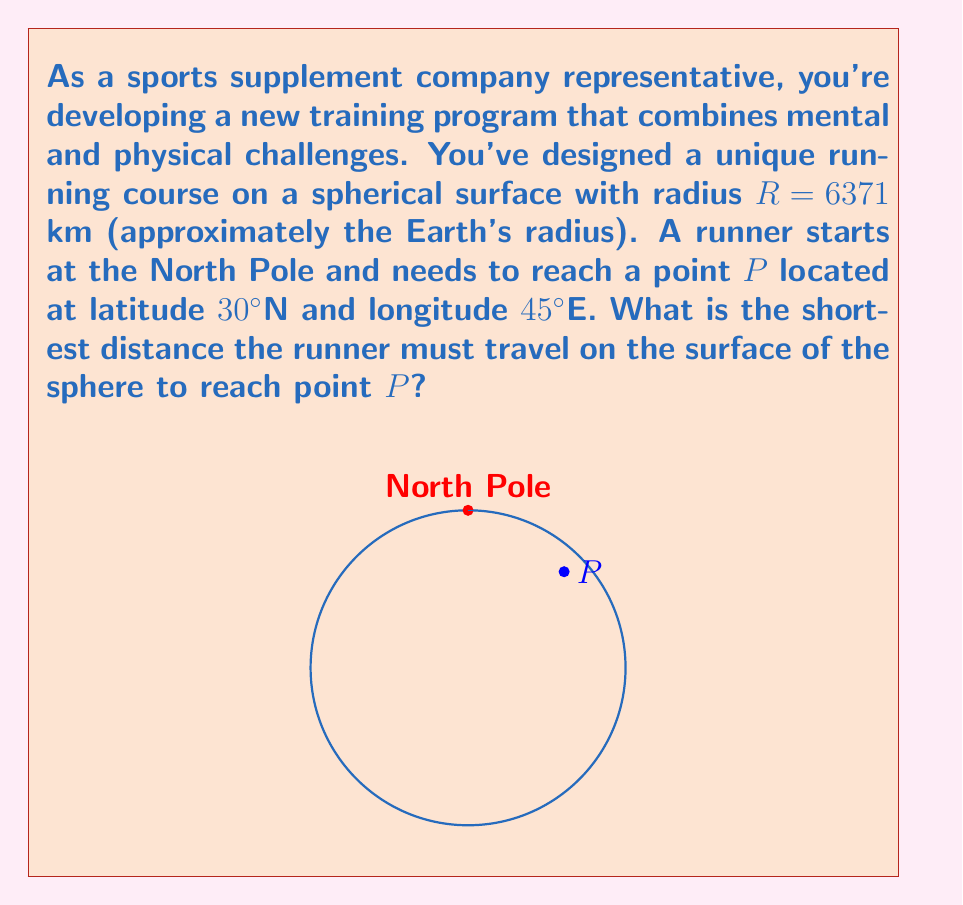Provide a solution to this math problem. To solve this problem, we need to use concepts from spherical geometry:

1) The shortest path between two points on a sphere is along a great circle, which is the intersection of the sphere with a plane passing through its center and both points.

2) The distance along this great circle is given by the arc length formula:
   $$s = R\theta$$
   where $s$ is the arc length, $R$ is the radius, and $\theta$ is the central angle in radians.

3) To find $\theta$, we can use the spherical law of cosines:
   $$\cos(\theta) = \sin(\phi_1)\sin(\phi_2) + \cos(\phi_1)\cos(\phi_2)\cos(\Delta\lambda)$$
   where $\phi_1$ and $\phi_2$ are the latitudes of the two points, and $\Delta\lambda$ is the difference in longitude.

4) In our case:
   - $\phi_1 = 90°$ (North Pole)
   - $\phi_2 = 30°$ (Point P)
   - $\Delta\lambda = 45°$

5) Plugging these into the formula:
   $$\cos(\theta) = \sin(90°)\sin(30°) + \cos(90°)\cos(30°)\cos(45°)$$
   $$= 0.5 + 0 = 0.5$$

6) Therefore:
   $$\theta = \arccos(0.5) \approx 1.0472 \text{ radians}$$

7) Now we can calculate the distance:
   $$s = R\theta = 6371 \text{ km} \times 1.0472 \approx 6672 \text{ km}$$

This is the shortest distance the runner must travel on the surface of the sphere.
Answer: $6672 \text{ km}$ 